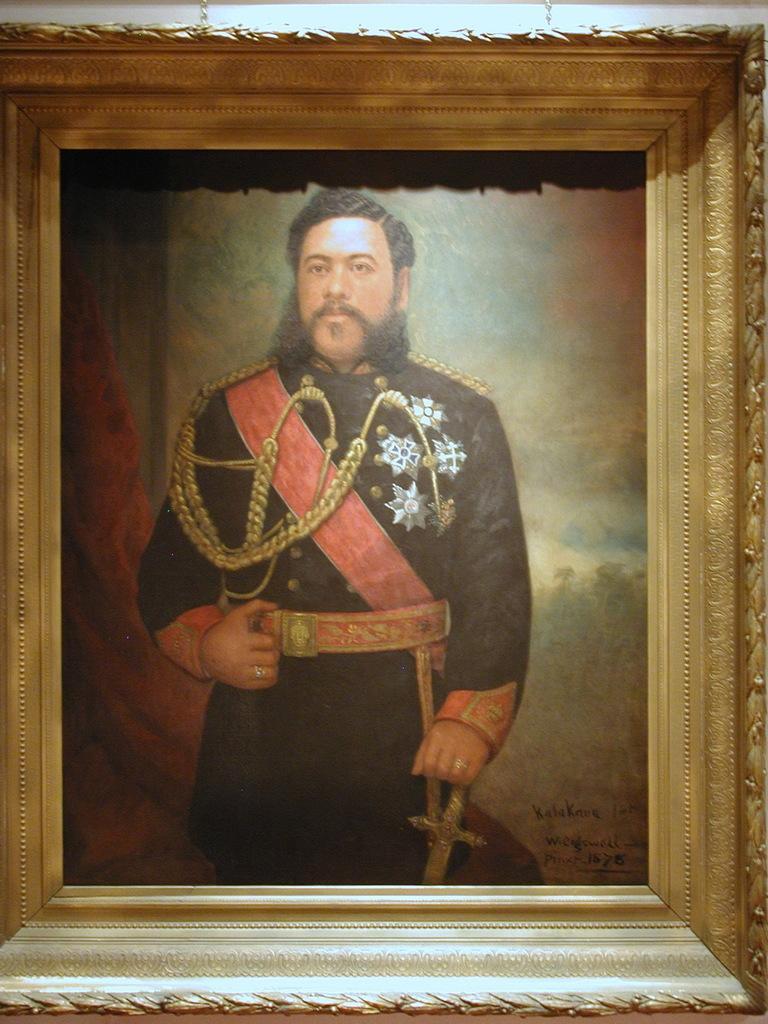Describe this image in one or two sentences. In this picture there is a photo frame of a person wearing black dress is standing and placed one of his hand on a sword and there is something written in the right bottom corner. 